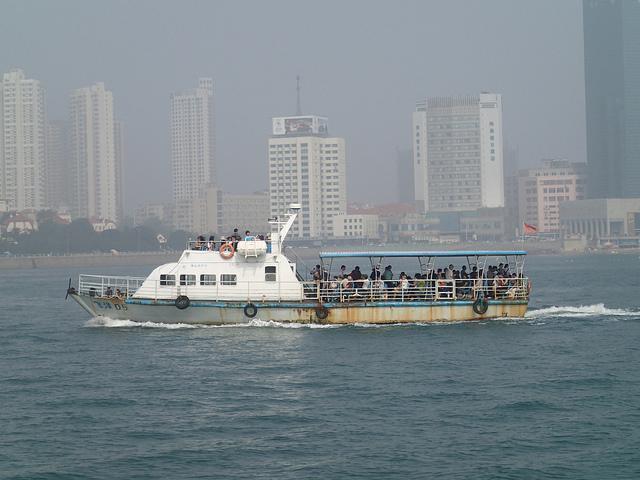Where are the people on the boat ultimately headed?
Make your selection from the four choices given to correctly answer the question.
Options: Mexico city, thailand, near shore, laguardia. Near shore. 